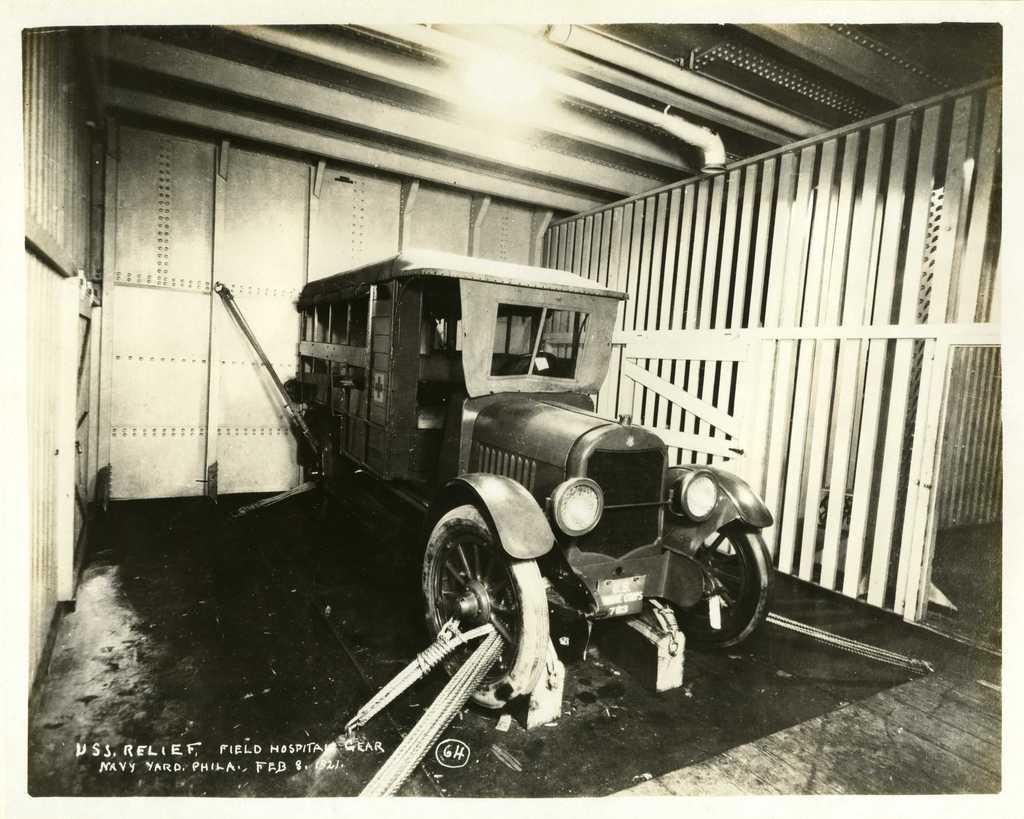Describe this image in one or two sentences. In this image there is a car, there is a wooden floor towards the bottom of the image, there is an object that looks like a mat on the wooden floor, there is text towards the bottom of the image, there is number towards the bottom of the image, there is a wall, there is a roof towards the top of the image, there is a light towards the top of the image. 